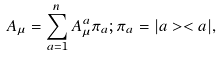Convert formula to latex. <formula><loc_0><loc_0><loc_500><loc_500>A _ { \mu } = \sum _ { a = 1 } ^ { n } A _ { \mu } ^ { a } \pi _ { a } ; \pi _ { a } = | a > < a | ,</formula> 